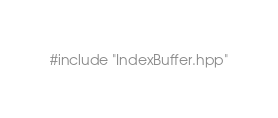<code> <loc_0><loc_0><loc_500><loc_500><_C++_>#include "IndexBuffer.hpp"

</code> 